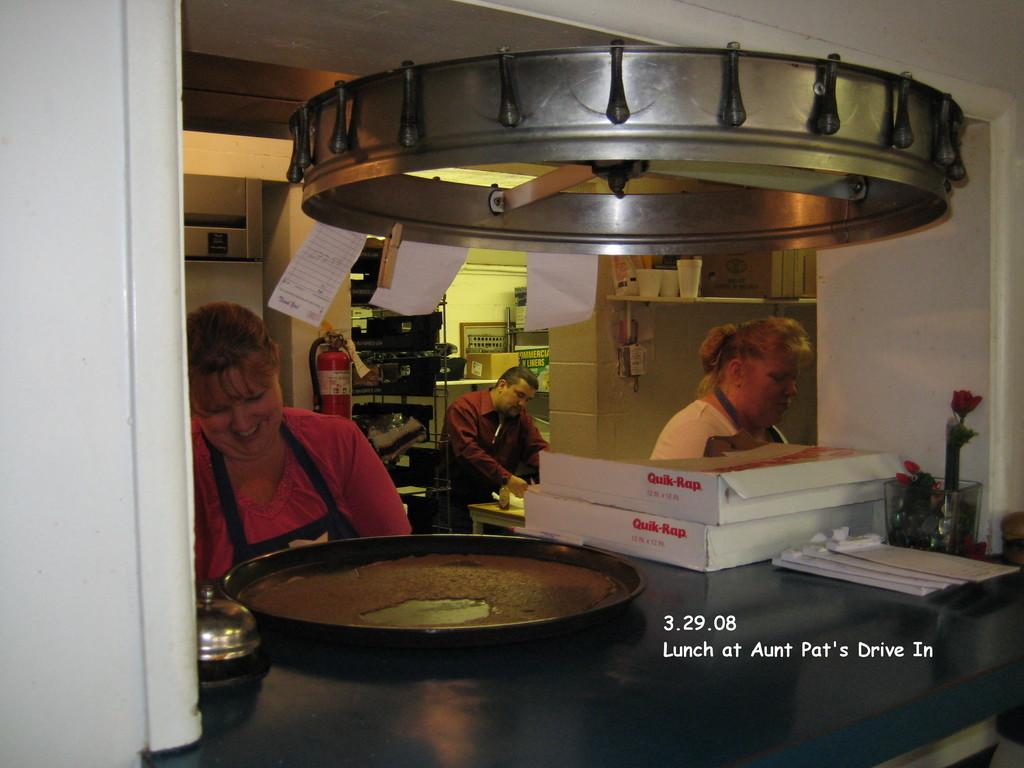Provide a one-sentence caption for the provided image. Three people are making pizzas and two pizza boxes say Quik-Rap on it. 